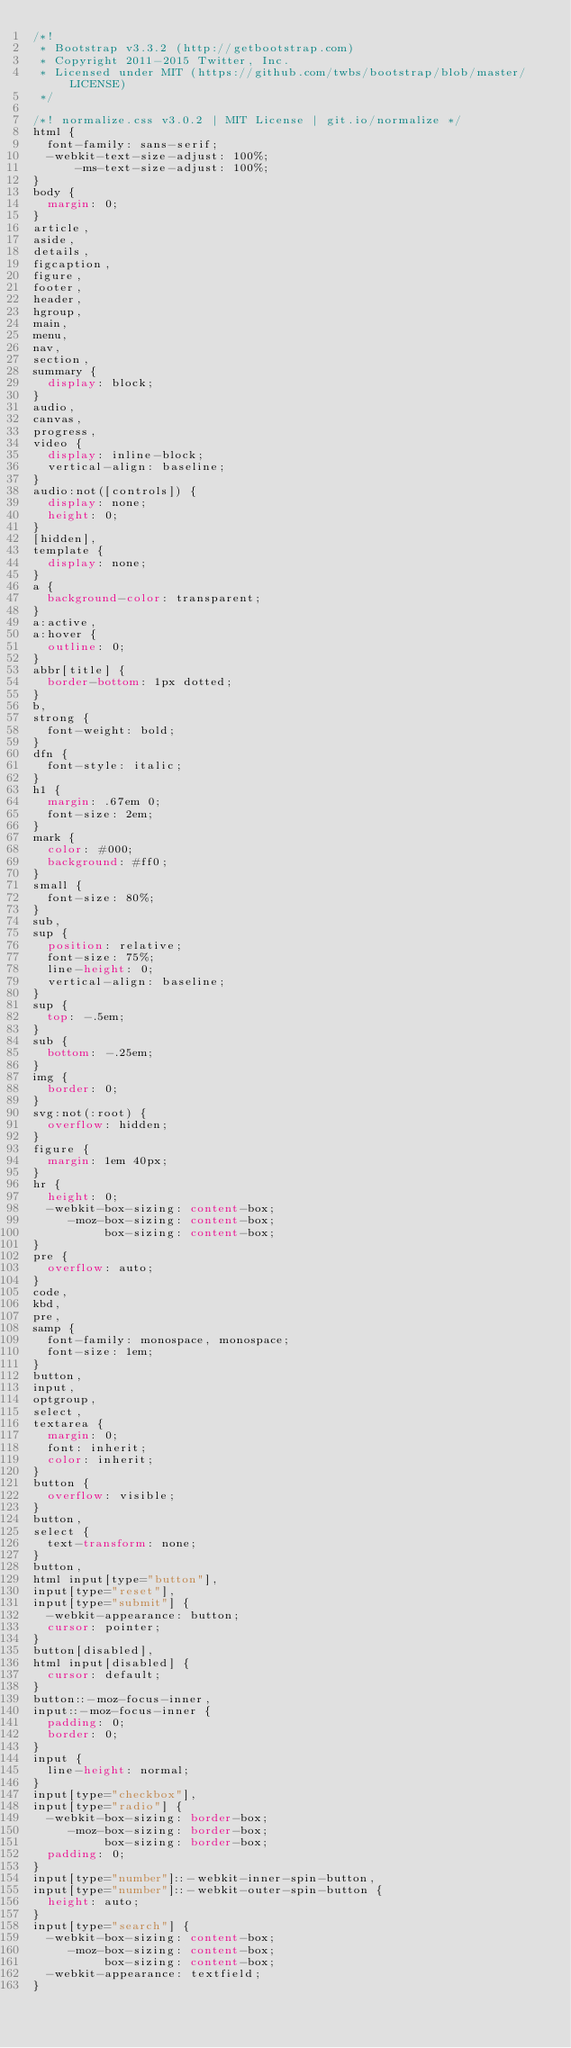<code> <loc_0><loc_0><loc_500><loc_500><_CSS_>/*!
 * Bootstrap v3.3.2 (http://getbootstrap.com)
 * Copyright 2011-2015 Twitter, Inc.
 * Licensed under MIT (https://github.com/twbs/bootstrap/blob/master/LICENSE)
 */

/*! normalize.css v3.0.2 | MIT License | git.io/normalize */
html {
  font-family: sans-serif;
  -webkit-text-size-adjust: 100%;
      -ms-text-size-adjust: 100%;
}
body {
  margin: 0;
}
article,
aside,
details,
figcaption,
figure,
footer,
header,
hgroup,
main,
menu,
nav,
section,
summary {
  display: block;
}
audio,
canvas,
progress,
video {
  display: inline-block;
  vertical-align: baseline;
}
audio:not([controls]) {
  display: none;
  height: 0;
}
[hidden],
template {
  display: none;
}
a {
  background-color: transparent;
}
a:active,
a:hover {
  outline: 0;
}
abbr[title] {
  border-bottom: 1px dotted;
}
b,
strong {
  font-weight: bold;
}
dfn {
  font-style: italic;
}
h1 {
  margin: .67em 0;
  font-size: 2em;
}
mark {
  color: #000;
  background: #ff0;
}
small {
  font-size: 80%;
}
sub,
sup {
  position: relative;
  font-size: 75%;
  line-height: 0;
  vertical-align: baseline;
}
sup {
  top: -.5em;
}
sub {
  bottom: -.25em;
}
img {
  border: 0;
}
svg:not(:root) {
  overflow: hidden;
}
figure {
  margin: 1em 40px;
}
hr {
  height: 0;
  -webkit-box-sizing: content-box;
     -moz-box-sizing: content-box;
          box-sizing: content-box;
}
pre {
  overflow: auto;
}
code,
kbd,
pre,
samp {
  font-family: monospace, monospace;
  font-size: 1em;
}
button,
input,
optgroup,
select,
textarea {
  margin: 0;
  font: inherit;
  color: inherit;
}
button {
  overflow: visible;
}
button,
select {
  text-transform: none;
}
button,
html input[type="button"],
input[type="reset"],
input[type="submit"] {
  -webkit-appearance: button;
  cursor: pointer;
}
button[disabled],
html input[disabled] {
  cursor: default;
}
button::-moz-focus-inner,
input::-moz-focus-inner {
  padding: 0;
  border: 0;
}
input {
  line-height: normal;
}
input[type="checkbox"],
input[type="radio"] {
  -webkit-box-sizing: border-box;
     -moz-box-sizing: border-box;
          box-sizing: border-box;
  padding: 0;
}
input[type="number"]::-webkit-inner-spin-button,
input[type="number"]::-webkit-outer-spin-button {
  height: auto;
}
input[type="search"] {
  -webkit-box-sizing: content-box;
     -moz-box-sizing: content-box;
          box-sizing: content-box;
  -webkit-appearance: textfield;
}</code> 